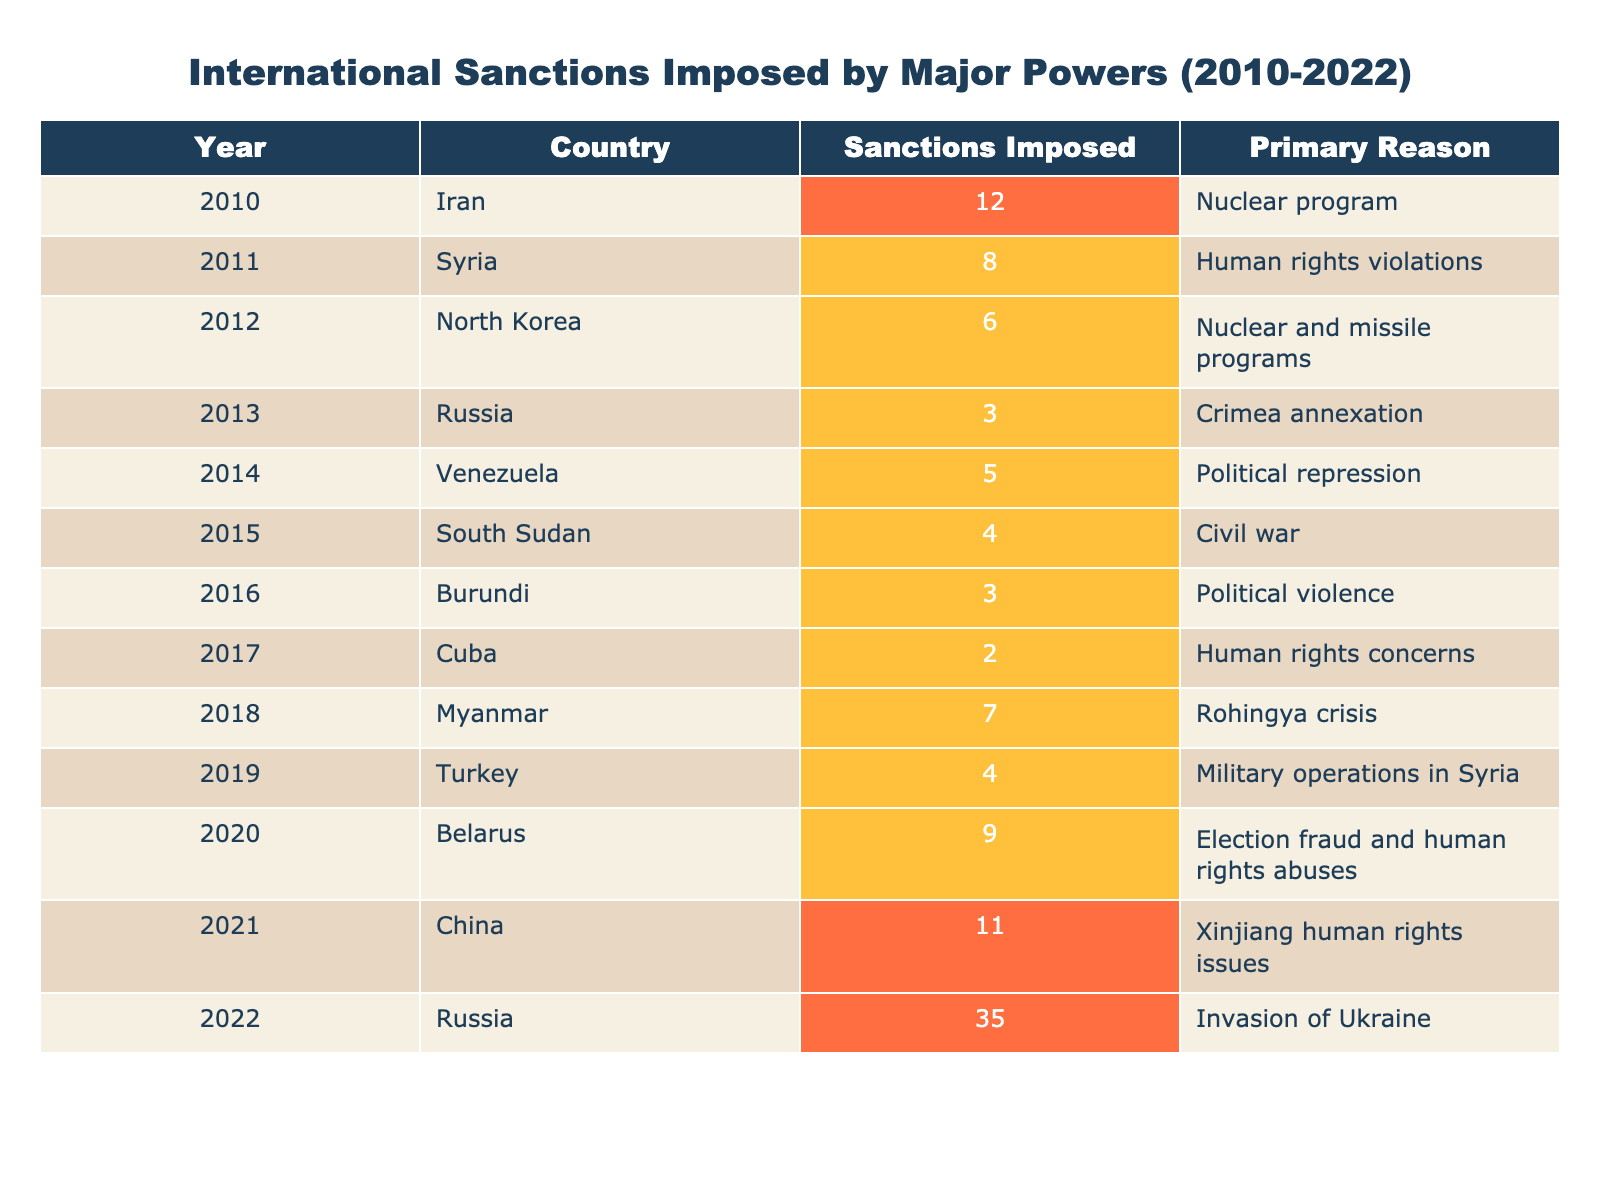What country had the highest number of sanctions imposed in 2022? In 2022, Russia had the highest number of sanctions imposed, totaling 35. This information is taken directly from the "Sanctions Imposed" column for the year 2022.
Answer: Russia Which country was sanctioned the most times between 2010 and 2022? Reviewing the "Sanctions Imposed" column, Russia received a total of 38 sanctions (3 in 2014 and 35 in 2022), more than any other country listed in the table.
Answer: Russia What is the total number of sanctions imposed on Iran from 2010 to 2022? Iran had 12 sanctions imposed in 2010 and no further sanctions noted in the subsequent years, leading to a total of 12 sanctions directly taken from the table.
Answer: 12 How many sanctions were imposed on Venezuela compared to North Korea? Venezuela had 5 sanctions imposed in 2014, while North Korea had 6 sanctions imposed in 2012. Therefore, North Korea had 1 more sanction than Venezuela.
Answer: North Korea had 1 more sanction than Venezuela Which country saw an increase in sanctions from one year to the next between 2014 and 2022? An analysis shows that Russia increased its sanctions from 3 in 2014 to 35 in 2022, representing a significant increase during that period.
Answer: Russia What is the average number of sanctions imposed per year from 2010 to 2022? The total sanctions from 2010 to 2022 sum up to 92 (12+8+6+3+5+4+3+2+7+4+9+11+35). With 13 years, the average is 92/13 = approximately 7.08.
Answer: Approximately 7.08 Was there any year without sanctions imposed? Scanning the table shows that every year from 2010 to 2022 lists at least one country with sanctions imposed, confirming that there were no years without sanctions.
Answer: No What were the primary reasons for the sanctions against Belarus in 2020? According to the table, the sanctions against Belarus in 2020 were primarily due to election fraud and human rights abuses, as stated in the relevant entry.
Answer: Election fraud and human rights abuses How does the frequency of sanctions against China in 2021 compare to that of Cuba in 2017? China had 11 sanctions imposed in 2021, while Cuba had only 2 sanctions in 2017. This suggests that China faced 9 more sanctions than Cuba.
Answer: China faced 9 more sanctions than Cuba What are the two main reasons for the sanctions imposed on Syria? The sanctions imposed on Syria in 2011 were primarily due to human rights violations, as per the entry in the table. There is no data indicating they had additional reasons listed specifically in the table.
Answer: Human rights violations 